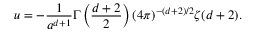<formula> <loc_0><loc_0><loc_500><loc_500>u = - { \frac { 1 } { a ^ { d + 1 } } } \Gamma \left ( { \frac { d + 2 } { 2 } } \right ) ( 4 \pi ) ^ { - ( d + 2 ) / 2 } \zeta ( d + 2 ) .</formula> 